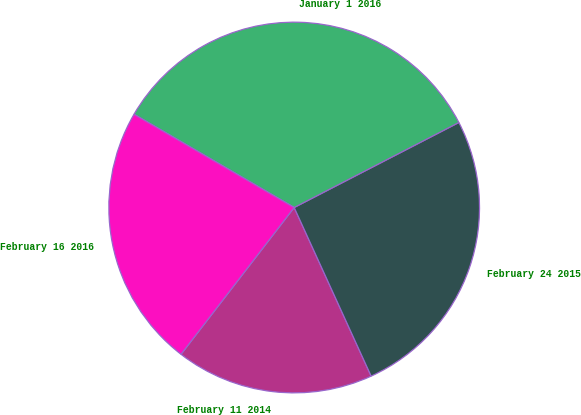Convert chart. <chart><loc_0><loc_0><loc_500><loc_500><pie_chart><fcel>February 11 2014<fcel>February 24 2015<fcel>January 1 2016<fcel>February 16 2016<nl><fcel>17.27%<fcel>25.77%<fcel>34.02%<fcel>22.94%<nl></chart> 